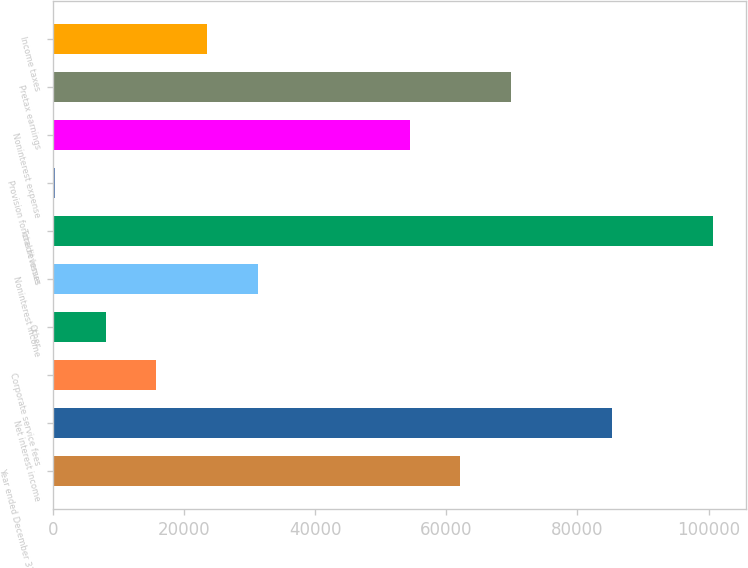<chart> <loc_0><loc_0><loc_500><loc_500><bar_chart><fcel>Year ended December 31 Dollars<fcel>Net interest income<fcel>Corporate service fees<fcel>Other<fcel>Noninterest income<fcel>Total revenue<fcel>Provision for credit losses<fcel>Noninterest expense<fcel>Pretax earnings<fcel>Income taxes<nl><fcel>62092.6<fcel>85263.7<fcel>15750.4<fcel>8026.7<fcel>31197.8<fcel>100711<fcel>303<fcel>54368.9<fcel>69816.3<fcel>23474.1<nl></chart> 